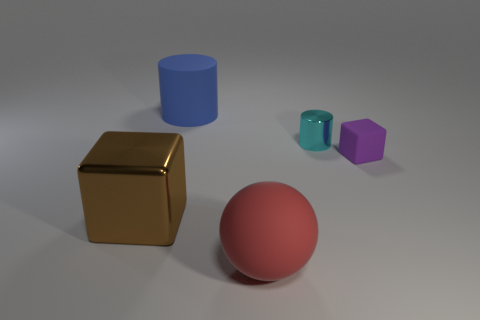There is a cyan thing that is the same shape as the large blue matte thing; what is its size? The cyan object is small compared to the large blue cylinder, indicating it's a miniature version of the larger shape. 